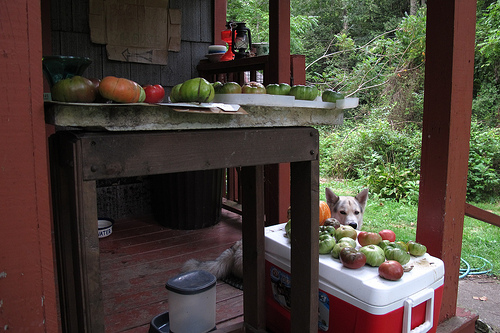<image>
Is there a tomato on the table? No. The tomato is not positioned on the table. They may be near each other, but the tomato is not supported by or resting on top of the table. Is there a dog behind the table? Yes. From this viewpoint, the dog is positioned behind the table, with the table partially or fully occluding the dog. 